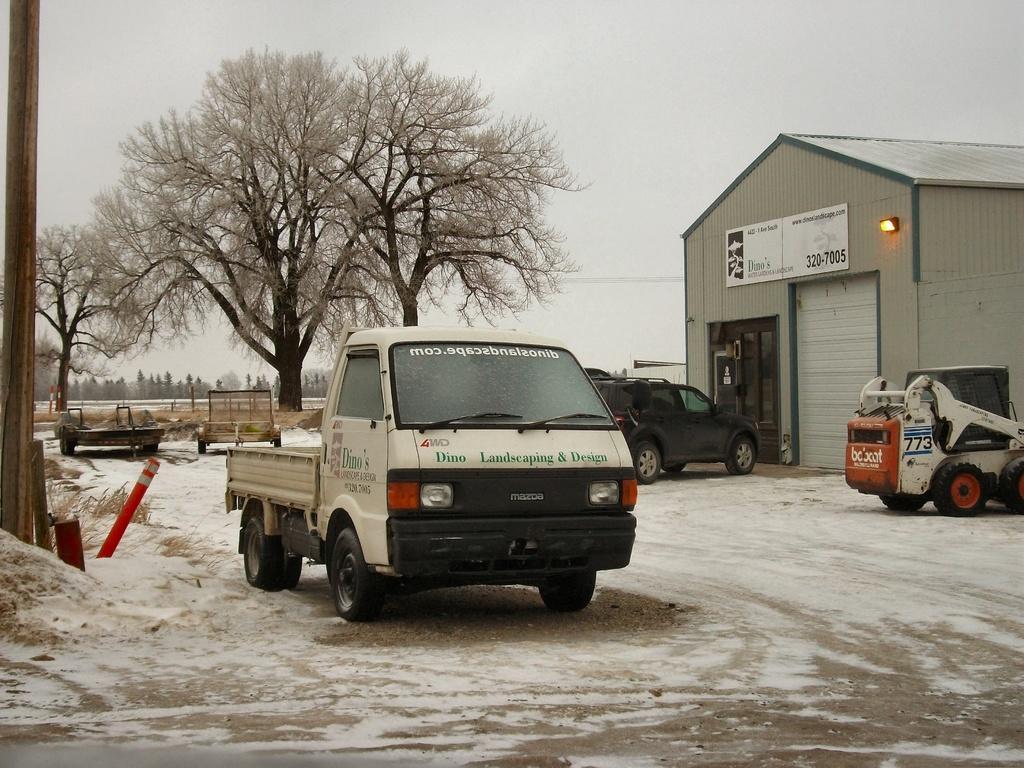Please provide a concise description of this image. In this image we can see vehicles. In the background of the image there are trees. To the left side of the image there is a pole and safety pole. To the right side of the image there is house with a board and some text on it. At the bottom of the image there is road with snow on it. 